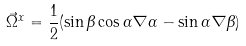Convert formula to latex. <formula><loc_0><loc_0><loc_500><loc_500>\vec { \Omega } ^ { x } = \frac { 1 } { 2 } ( \sin \beta \cos \alpha \nabla \alpha - \sin \alpha \nabla \beta )</formula> 